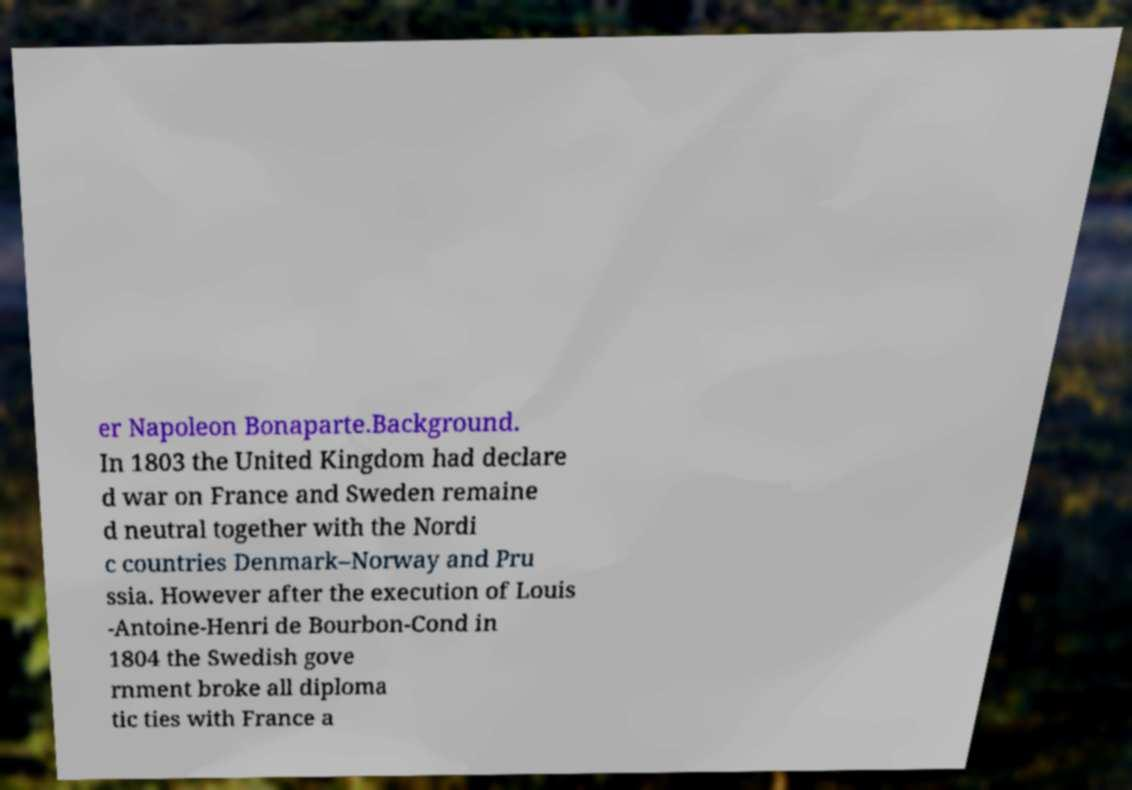Please identify and transcribe the text found in this image. er Napoleon Bonaparte.Background. In 1803 the United Kingdom had declare d war on France and Sweden remaine d neutral together with the Nordi c countries Denmark–Norway and Pru ssia. However after the execution of Louis -Antoine-Henri de Bourbon-Cond in 1804 the Swedish gove rnment broke all diploma tic ties with France a 